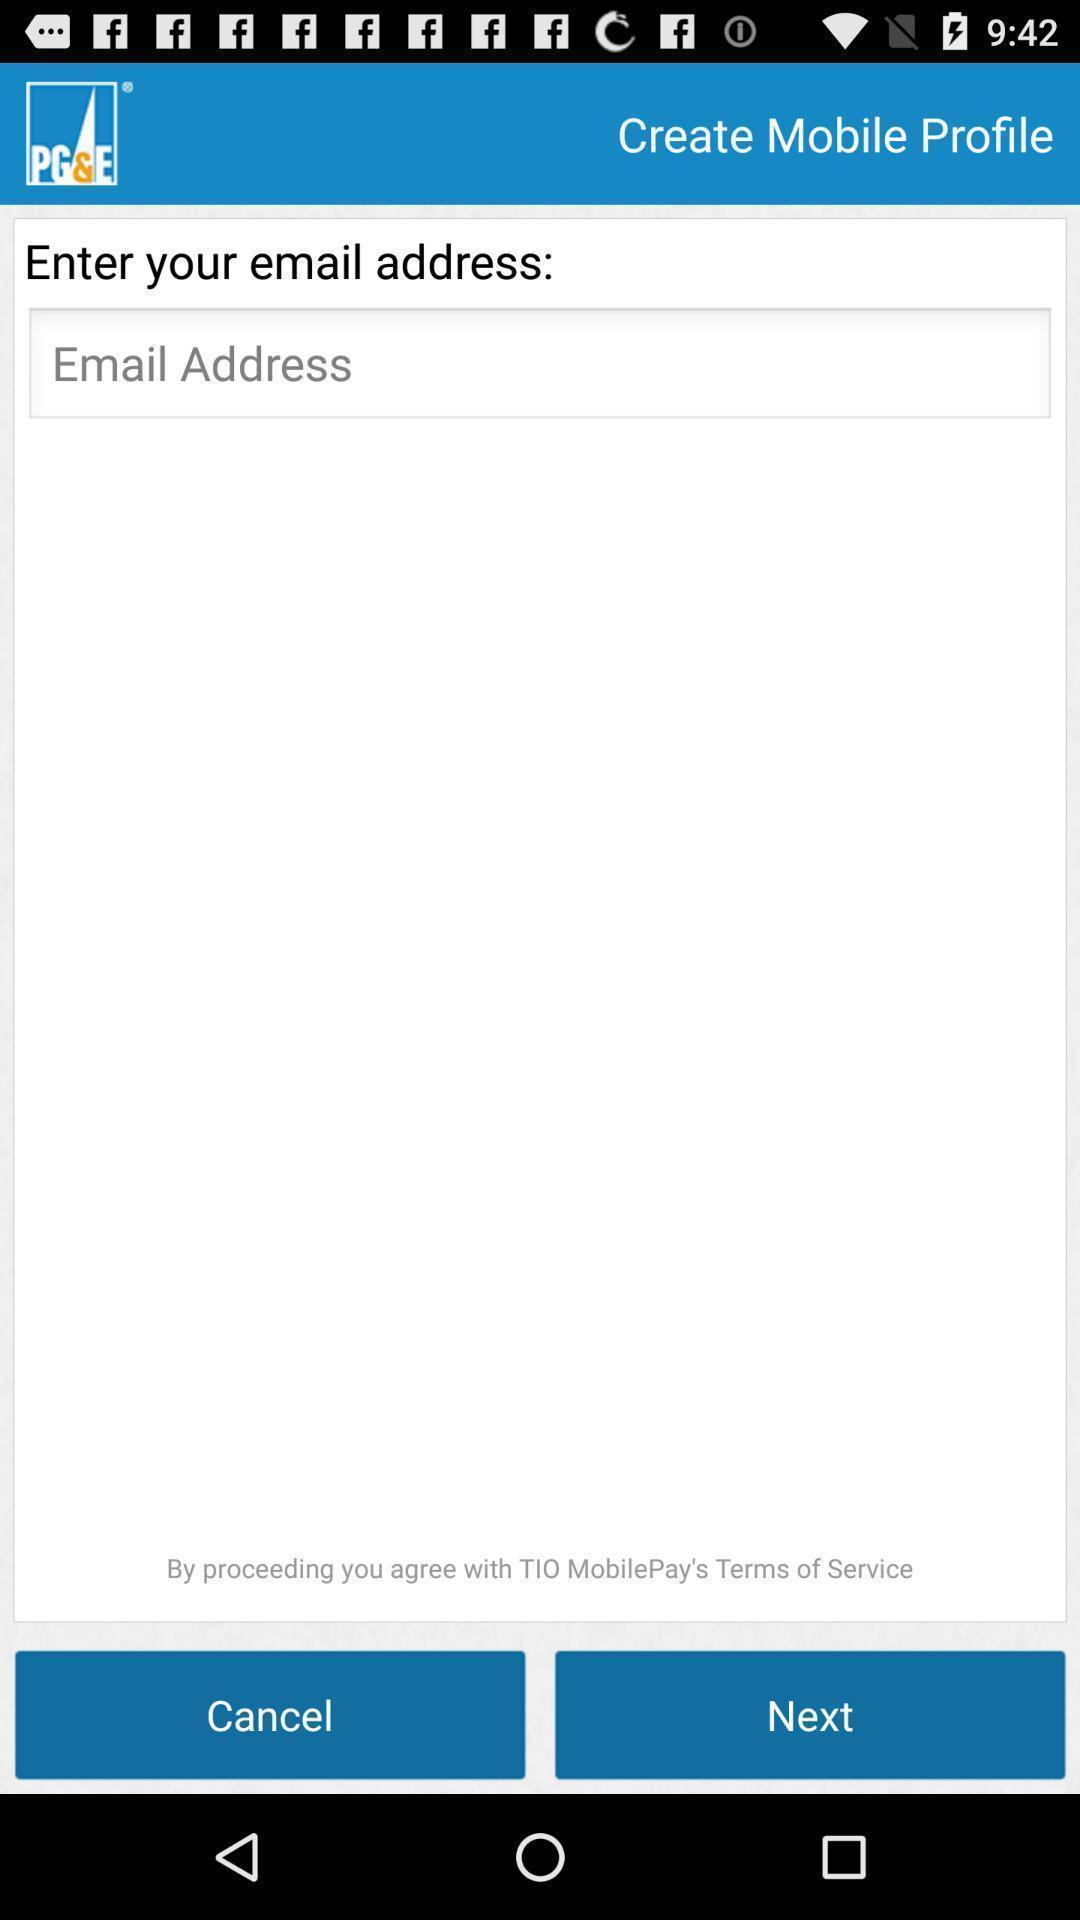What can you discern from this picture? Text bar of email address in a profile creating page. 